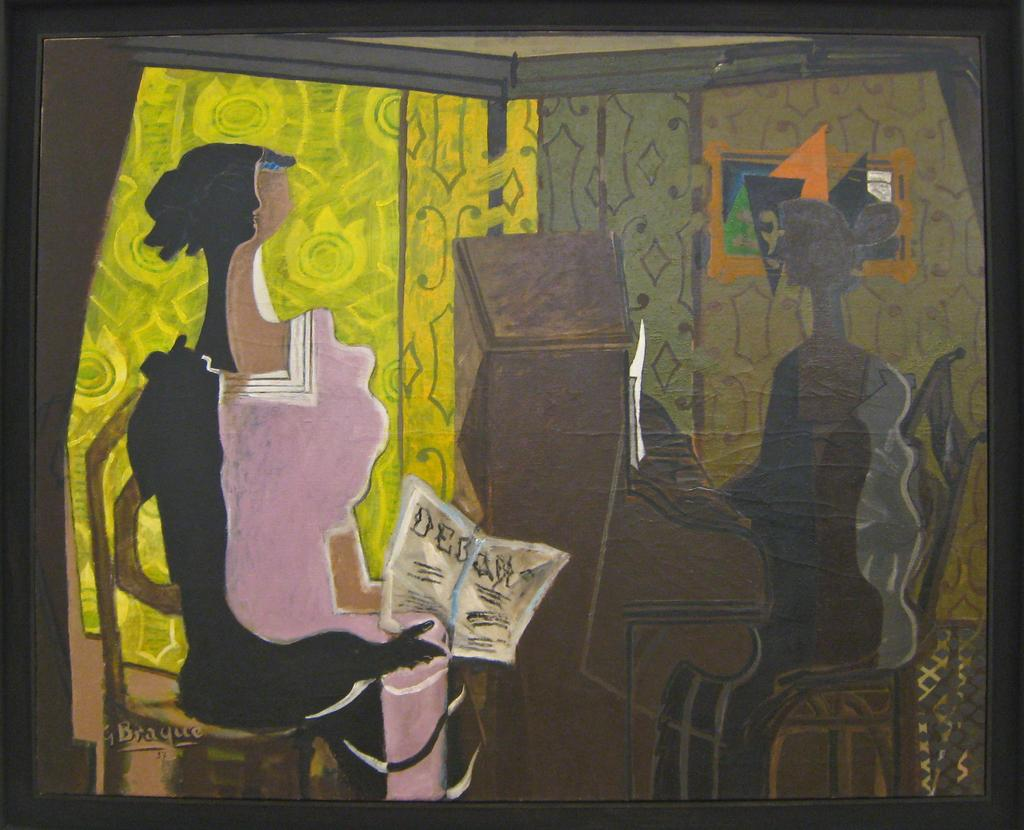What is the main subject of the image? There is a painting in the image. What are the two persons in the painting doing? One person is holding a book, and another person is playing a piano in the painting. Can you describe the activities of the persons in the painting? One person is reading a book, and another person is playing a musical instrument, the piano. What color is the shirt of the cat in the image? There is no cat present in the image; it features a painting with two persons. How does the person in the painting feel about their crush while playing the piano? The image does not provide information about the person's feelings or any potential crush, as it only shows the person playing the piano and holding a book. 